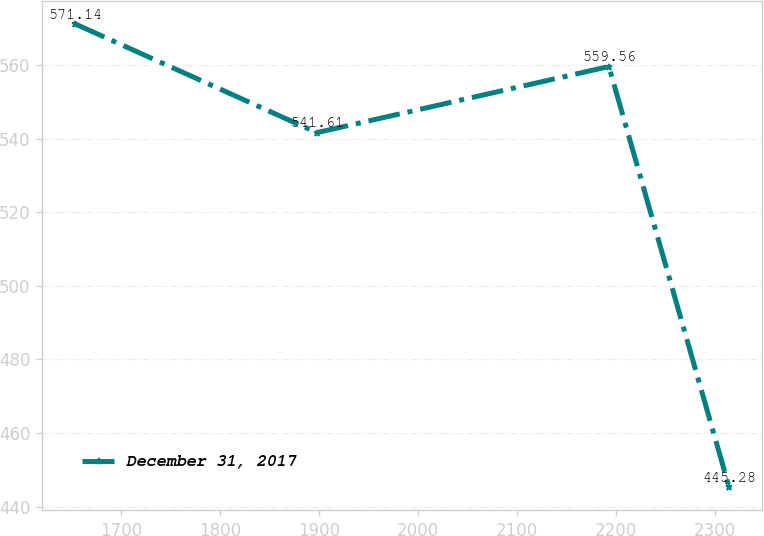<chart> <loc_0><loc_0><loc_500><loc_500><line_chart><ecel><fcel>December 31, 2017<nl><fcel>1653.23<fcel>571.14<nl><fcel>1897.67<fcel>541.61<nl><fcel>2192.81<fcel>559.56<nl><fcel>2314.34<fcel>445.28<nl></chart> 